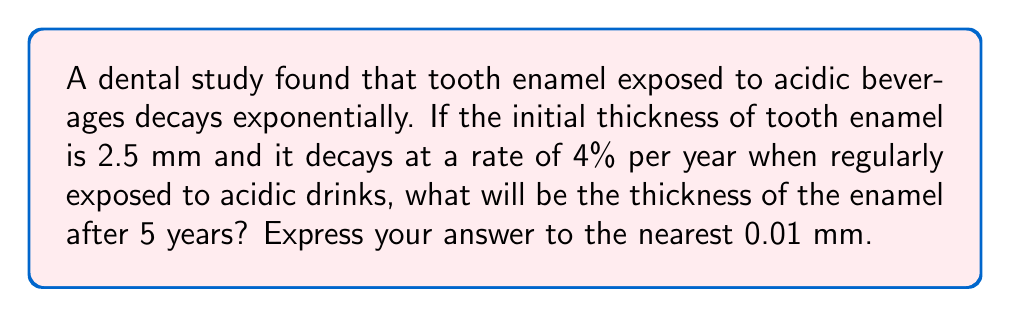Teach me how to tackle this problem. Let's approach this step-by-step using an exponential decay function:

1) The general form of exponential decay is:
   $$A(t) = A_0 \cdot (1-r)^t$$
   where $A(t)$ is the amount at time $t$, $A_0$ is the initial amount, $r$ is the decay rate, and $t$ is the time.

2) In this case:
   $A_0 = 2.5$ mm (initial thickness)
   $r = 0.04$ (4% decay rate)
   $t = 5$ years

3) Plugging these values into our equation:
   $$A(5) = 2.5 \cdot (1-0.04)^5$$

4) Simplify inside the parentheses:
   $$A(5) = 2.5 \cdot (0.96)^5$$

5) Calculate $(0.96)^5$:
   $$(0.96)^5 \approx 0.8185$$

6) Multiply:
   $$A(5) = 2.5 \cdot 0.8185 \approx 2.0463$$

7) Rounding to the nearest 0.01 mm:
   $$A(5) \approx 2.05 \text{ mm}$$

Therefore, after 5 years, the thickness of the enamel will be approximately 2.05 mm.
Answer: 2.05 mm 